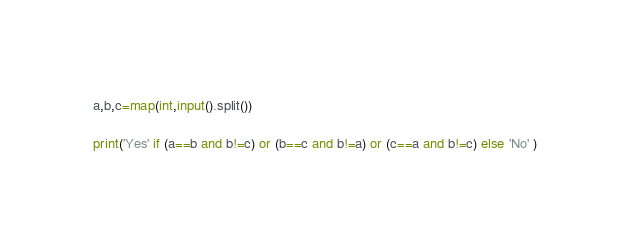<code> <loc_0><loc_0><loc_500><loc_500><_Python_>a,b,c=map(int,input().split())

print('Yes' if (a==b and b!=c) or (b==c and b!=a) or (c==a and b!=c) else 'No' )</code> 